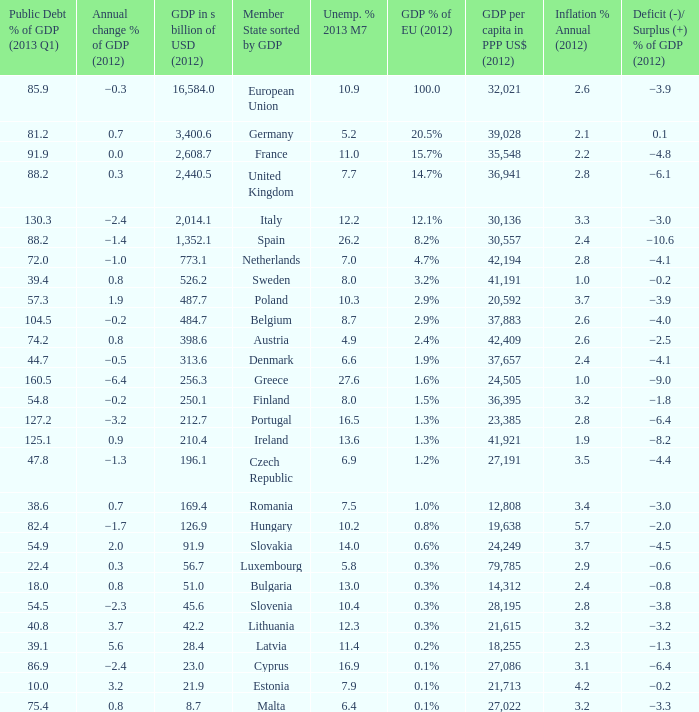What is the greatest annual inflation rate in 2012 for the country with a public debt ratio of gdp in 2013 q1 above 8 2.6. 